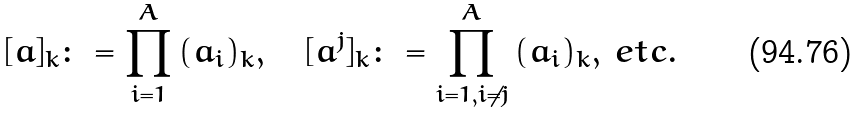<formula> <loc_0><loc_0><loc_500><loc_500>[ a ] _ { k } \colon = \prod _ { i = 1 } ^ { A } \, ( a _ { i } ) _ { k } , \quad [ a ^ { j } ] _ { k } \colon = \prod _ { i = 1 , i \neq j } ^ { A } \, ( a _ { i } ) _ { k } , \, e t c .</formula> 